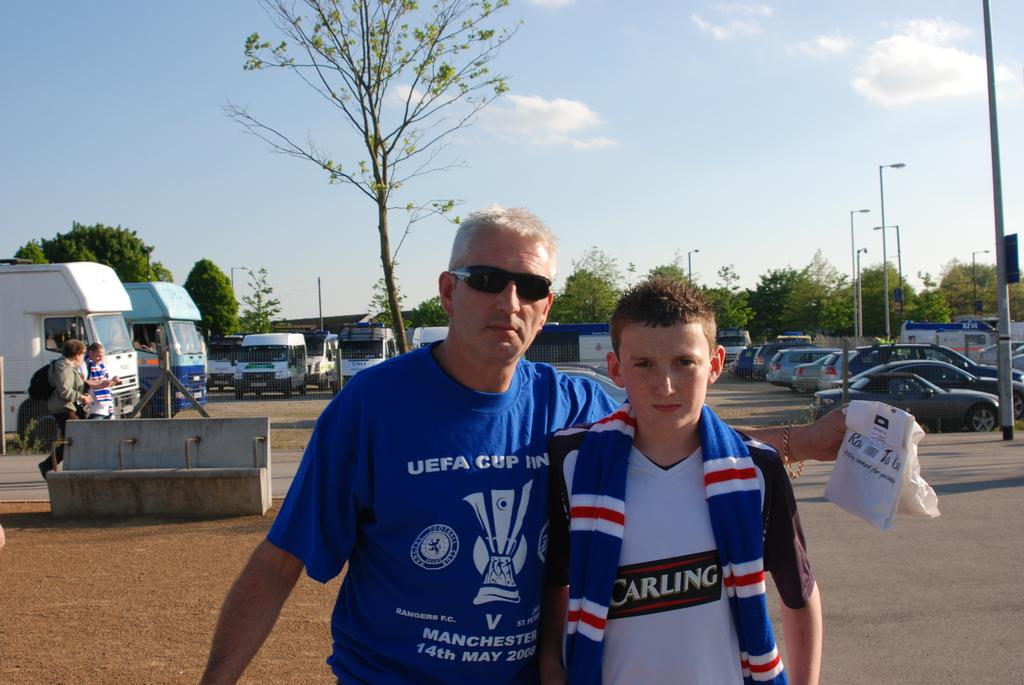What date is on the man's shirt?
Your answer should be compact. 14th may 2008. What is the cup on the mans shirt?
Provide a succinct answer. Uefa. 